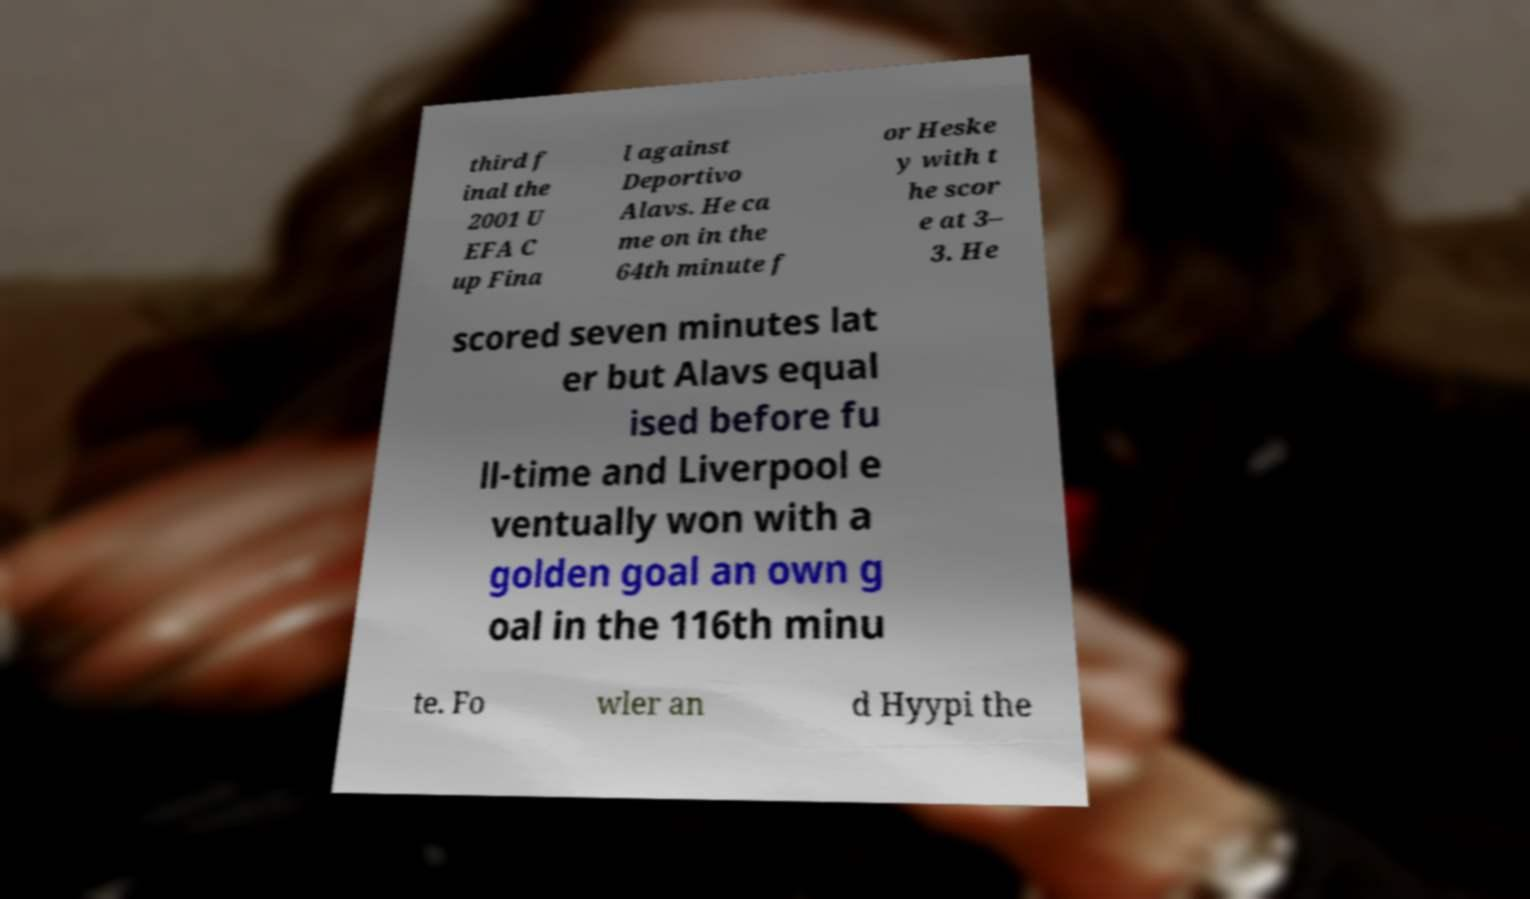Could you assist in decoding the text presented in this image and type it out clearly? third f inal the 2001 U EFA C up Fina l against Deportivo Alavs. He ca me on in the 64th minute f or Heske y with t he scor e at 3– 3. He scored seven minutes lat er but Alavs equal ised before fu ll-time and Liverpool e ventually won with a golden goal an own g oal in the 116th minu te. Fo wler an d Hyypi the 